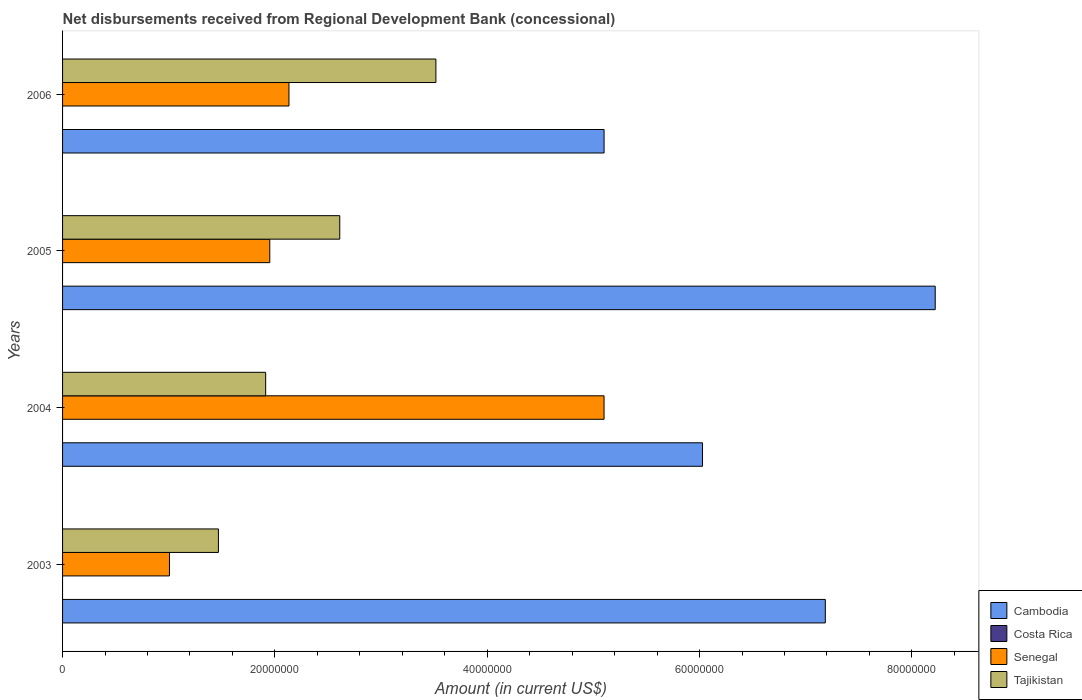How many groups of bars are there?
Your answer should be very brief. 4. Are the number of bars per tick equal to the number of legend labels?
Offer a terse response. No. How many bars are there on the 3rd tick from the bottom?
Your response must be concise. 3. What is the label of the 4th group of bars from the top?
Your response must be concise. 2003. In how many cases, is the number of bars for a given year not equal to the number of legend labels?
Give a very brief answer. 4. What is the amount of disbursements received from Regional Development Bank in Tajikistan in 2003?
Offer a terse response. 1.47e+07. Across all years, what is the maximum amount of disbursements received from Regional Development Bank in Cambodia?
Ensure brevity in your answer.  8.22e+07. Across all years, what is the minimum amount of disbursements received from Regional Development Bank in Cambodia?
Your response must be concise. 5.10e+07. What is the total amount of disbursements received from Regional Development Bank in Senegal in the graph?
Your answer should be compact. 1.02e+08. What is the difference between the amount of disbursements received from Regional Development Bank in Tajikistan in 2004 and that in 2005?
Make the answer very short. -6.98e+06. What is the difference between the amount of disbursements received from Regional Development Bank in Tajikistan in 2004 and the amount of disbursements received from Regional Development Bank in Senegal in 2003?
Your answer should be very brief. 9.06e+06. What is the average amount of disbursements received from Regional Development Bank in Cambodia per year?
Offer a terse response. 6.63e+07. In the year 2006, what is the difference between the amount of disbursements received from Regional Development Bank in Senegal and amount of disbursements received from Regional Development Bank in Cambodia?
Offer a terse response. -2.97e+07. In how many years, is the amount of disbursements received from Regional Development Bank in Cambodia greater than 68000000 US$?
Make the answer very short. 2. What is the ratio of the amount of disbursements received from Regional Development Bank in Senegal in 2004 to that in 2006?
Your response must be concise. 2.39. Is the difference between the amount of disbursements received from Regional Development Bank in Senegal in 2004 and 2006 greater than the difference between the amount of disbursements received from Regional Development Bank in Cambodia in 2004 and 2006?
Offer a terse response. Yes. What is the difference between the highest and the second highest amount of disbursements received from Regional Development Bank in Cambodia?
Your response must be concise. 1.04e+07. What is the difference between the highest and the lowest amount of disbursements received from Regional Development Bank in Senegal?
Provide a short and direct response. 4.09e+07. How many years are there in the graph?
Offer a terse response. 4. Are the values on the major ticks of X-axis written in scientific E-notation?
Offer a terse response. No. Does the graph contain any zero values?
Ensure brevity in your answer.  Yes. Where does the legend appear in the graph?
Offer a terse response. Bottom right. How are the legend labels stacked?
Keep it short and to the point. Vertical. What is the title of the graph?
Your answer should be compact. Net disbursements received from Regional Development Bank (concessional). What is the Amount (in current US$) of Cambodia in 2003?
Your response must be concise. 7.18e+07. What is the Amount (in current US$) of Costa Rica in 2003?
Give a very brief answer. 0. What is the Amount (in current US$) of Senegal in 2003?
Give a very brief answer. 1.01e+07. What is the Amount (in current US$) in Tajikistan in 2003?
Offer a terse response. 1.47e+07. What is the Amount (in current US$) of Cambodia in 2004?
Offer a terse response. 6.03e+07. What is the Amount (in current US$) of Senegal in 2004?
Offer a terse response. 5.10e+07. What is the Amount (in current US$) in Tajikistan in 2004?
Your answer should be compact. 1.91e+07. What is the Amount (in current US$) in Cambodia in 2005?
Offer a terse response. 8.22e+07. What is the Amount (in current US$) in Costa Rica in 2005?
Keep it short and to the point. 0. What is the Amount (in current US$) of Senegal in 2005?
Your response must be concise. 1.95e+07. What is the Amount (in current US$) of Tajikistan in 2005?
Your response must be concise. 2.61e+07. What is the Amount (in current US$) in Cambodia in 2006?
Provide a succinct answer. 5.10e+07. What is the Amount (in current US$) of Costa Rica in 2006?
Make the answer very short. 0. What is the Amount (in current US$) in Senegal in 2006?
Your answer should be compact. 2.13e+07. What is the Amount (in current US$) of Tajikistan in 2006?
Provide a short and direct response. 3.52e+07. Across all years, what is the maximum Amount (in current US$) in Cambodia?
Give a very brief answer. 8.22e+07. Across all years, what is the maximum Amount (in current US$) of Senegal?
Provide a succinct answer. 5.10e+07. Across all years, what is the maximum Amount (in current US$) of Tajikistan?
Your answer should be very brief. 3.52e+07. Across all years, what is the minimum Amount (in current US$) of Cambodia?
Provide a succinct answer. 5.10e+07. Across all years, what is the minimum Amount (in current US$) of Senegal?
Ensure brevity in your answer.  1.01e+07. Across all years, what is the minimum Amount (in current US$) of Tajikistan?
Keep it short and to the point. 1.47e+07. What is the total Amount (in current US$) of Cambodia in the graph?
Your answer should be compact. 2.65e+08. What is the total Amount (in current US$) of Senegal in the graph?
Your answer should be very brief. 1.02e+08. What is the total Amount (in current US$) of Tajikistan in the graph?
Your response must be concise. 9.51e+07. What is the difference between the Amount (in current US$) of Cambodia in 2003 and that in 2004?
Keep it short and to the point. 1.16e+07. What is the difference between the Amount (in current US$) in Senegal in 2003 and that in 2004?
Make the answer very short. -4.09e+07. What is the difference between the Amount (in current US$) of Tajikistan in 2003 and that in 2004?
Keep it short and to the point. -4.45e+06. What is the difference between the Amount (in current US$) of Cambodia in 2003 and that in 2005?
Keep it short and to the point. -1.04e+07. What is the difference between the Amount (in current US$) of Senegal in 2003 and that in 2005?
Give a very brief answer. -9.45e+06. What is the difference between the Amount (in current US$) in Tajikistan in 2003 and that in 2005?
Your answer should be very brief. -1.14e+07. What is the difference between the Amount (in current US$) in Cambodia in 2003 and that in 2006?
Keep it short and to the point. 2.08e+07. What is the difference between the Amount (in current US$) in Senegal in 2003 and that in 2006?
Your answer should be very brief. -1.13e+07. What is the difference between the Amount (in current US$) in Tajikistan in 2003 and that in 2006?
Give a very brief answer. -2.05e+07. What is the difference between the Amount (in current US$) of Cambodia in 2004 and that in 2005?
Ensure brevity in your answer.  -2.19e+07. What is the difference between the Amount (in current US$) in Senegal in 2004 and that in 2005?
Keep it short and to the point. 3.15e+07. What is the difference between the Amount (in current US$) of Tajikistan in 2004 and that in 2005?
Provide a short and direct response. -6.98e+06. What is the difference between the Amount (in current US$) of Cambodia in 2004 and that in 2006?
Ensure brevity in your answer.  9.27e+06. What is the difference between the Amount (in current US$) in Senegal in 2004 and that in 2006?
Offer a terse response. 2.97e+07. What is the difference between the Amount (in current US$) of Tajikistan in 2004 and that in 2006?
Ensure brevity in your answer.  -1.60e+07. What is the difference between the Amount (in current US$) in Cambodia in 2005 and that in 2006?
Offer a very short reply. 3.12e+07. What is the difference between the Amount (in current US$) of Senegal in 2005 and that in 2006?
Offer a very short reply. -1.80e+06. What is the difference between the Amount (in current US$) of Tajikistan in 2005 and that in 2006?
Provide a succinct answer. -9.06e+06. What is the difference between the Amount (in current US$) in Cambodia in 2003 and the Amount (in current US$) in Senegal in 2004?
Ensure brevity in your answer.  2.08e+07. What is the difference between the Amount (in current US$) in Cambodia in 2003 and the Amount (in current US$) in Tajikistan in 2004?
Make the answer very short. 5.27e+07. What is the difference between the Amount (in current US$) in Senegal in 2003 and the Amount (in current US$) in Tajikistan in 2004?
Offer a very short reply. -9.06e+06. What is the difference between the Amount (in current US$) of Cambodia in 2003 and the Amount (in current US$) of Senegal in 2005?
Offer a very short reply. 5.23e+07. What is the difference between the Amount (in current US$) in Cambodia in 2003 and the Amount (in current US$) in Tajikistan in 2005?
Offer a terse response. 4.57e+07. What is the difference between the Amount (in current US$) in Senegal in 2003 and the Amount (in current US$) in Tajikistan in 2005?
Offer a terse response. -1.60e+07. What is the difference between the Amount (in current US$) in Cambodia in 2003 and the Amount (in current US$) in Senegal in 2006?
Your answer should be very brief. 5.05e+07. What is the difference between the Amount (in current US$) in Cambodia in 2003 and the Amount (in current US$) in Tajikistan in 2006?
Keep it short and to the point. 3.67e+07. What is the difference between the Amount (in current US$) of Senegal in 2003 and the Amount (in current US$) of Tajikistan in 2006?
Offer a very short reply. -2.51e+07. What is the difference between the Amount (in current US$) in Cambodia in 2004 and the Amount (in current US$) in Senegal in 2005?
Make the answer very short. 4.08e+07. What is the difference between the Amount (in current US$) in Cambodia in 2004 and the Amount (in current US$) in Tajikistan in 2005?
Your answer should be very brief. 3.42e+07. What is the difference between the Amount (in current US$) in Senegal in 2004 and the Amount (in current US$) in Tajikistan in 2005?
Ensure brevity in your answer.  2.49e+07. What is the difference between the Amount (in current US$) of Cambodia in 2004 and the Amount (in current US$) of Senegal in 2006?
Ensure brevity in your answer.  3.90e+07. What is the difference between the Amount (in current US$) in Cambodia in 2004 and the Amount (in current US$) in Tajikistan in 2006?
Provide a succinct answer. 2.51e+07. What is the difference between the Amount (in current US$) in Senegal in 2004 and the Amount (in current US$) in Tajikistan in 2006?
Ensure brevity in your answer.  1.58e+07. What is the difference between the Amount (in current US$) in Cambodia in 2005 and the Amount (in current US$) in Senegal in 2006?
Offer a very short reply. 6.09e+07. What is the difference between the Amount (in current US$) of Cambodia in 2005 and the Amount (in current US$) of Tajikistan in 2006?
Your response must be concise. 4.70e+07. What is the difference between the Amount (in current US$) of Senegal in 2005 and the Amount (in current US$) of Tajikistan in 2006?
Provide a short and direct response. -1.56e+07. What is the average Amount (in current US$) in Cambodia per year?
Offer a very short reply. 6.63e+07. What is the average Amount (in current US$) of Costa Rica per year?
Offer a very short reply. 0. What is the average Amount (in current US$) of Senegal per year?
Provide a short and direct response. 2.55e+07. What is the average Amount (in current US$) of Tajikistan per year?
Ensure brevity in your answer.  2.38e+07. In the year 2003, what is the difference between the Amount (in current US$) in Cambodia and Amount (in current US$) in Senegal?
Ensure brevity in your answer.  6.18e+07. In the year 2003, what is the difference between the Amount (in current US$) in Cambodia and Amount (in current US$) in Tajikistan?
Make the answer very short. 5.72e+07. In the year 2003, what is the difference between the Amount (in current US$) of Senegal and Amount (in current US$) of Tajikistan?
Give a very brief answer. -4.61e+06. In the year 2004, what is the difference between the Amount (in current US$) of Cambodia and Amount (in current US$) of Senegal?
Offer a very short reply. 9.27e+06. In the year 2004, what is the difference between the Amount (in current US$) of Cambodia and Amount (in current US$) of Tajikistan?
Ensure brevity in your answer.  4.11e+07. In the year 2004, what is the difference between the Amount (in current US$) of Senegal and Amount (in current US$) of Tajikistan?
Give a very brief answer. 3.19e+07. In the year 2005, what is the difference between the Amount (in current US$) in Cambodia and Amount (in current US$) in Senegal?
Provide a short and direct response. 6.27e+07. In the year 2005, what is the difference between the Amount (in current US$) in Cambodia and Amount (in current US$) in Tajikistan?
Give a very brief answer. 5.61e+07. In the year 2005, what is the difference between the Amount (in current US$) in Senegal and Amount (in current US$) in Tajikistan?
Provide a short and direct response. -6.59e+06. In the year 2006, what is the difference between the Amount (in current US$) of Cambodia and Amount (in current US$) of Senegal?
Offer a terse response. 2.97e+07. In the year 2006, what is the difference between the Amount (in current US$) of Cambodia and Amount (in current US$) of Tajikistan?
Your response must be concise. 1.58e+07. In the year 2006, what is the difference between the Amount (in current US$) in Senegal and Amount (in current US$) in Tajikistan?
Make the answer very short. -1.38e+07. What is the ratio of the Amount (in current US$) in Cambodia in 2003 to that in 2004?
Provide a succinct answer. 1.19. What is the ratio of the Amount (in current US$) in Senegal in 2003 to that in 2004?
Ensure brevity in your answer.  0.2. What is the ratio of the Amount (in current US$) of Tajikistan in 2003 to that in 2004?
Keep it short and to the point. 0.77. What is the ratio of the Amount (in current US$) in Cambodia in 2003 to that in 2005?
Your answer should be very brief. 0.87. What is the ratio of the Amount (in current US$) in Senegal in 2003 to that in 2005?
Give a very brief answer. 0.52. What is the ratio of the Amount (in current US$) of Tajikistan in 2003 to that in 2005?
Your response must be concise. 0.56. What is the ratio of the Amount (in current US$) in Cambodia in 2003 to that in 2006?
Your answer should be compact. 1.41. What is the ratio of the Amount (in current US$) of Senegal in 2003 to that in 2006?
Offer a terse response. 0.47. What is the ratio of the Amount (in current US$) in Tajikistan in 2003 to that in 2006?
Your answer should be compact. 0.42. What is the ratio of the Amount (in current US$) in Cambodia in 2004 to that in 2005?
Give a very brief answer. 0.73. What is the ratio of the Amount (in current US$) of Senegal in 2004 to that in 2005?
Make the answer very short. 2.61. What is the ratio of the Amount (in current US$) in Tajikistan in 2004 to that in 2005?
Make the answer very short. 0.73. What is the ratio of the Amount (in current US$) of Cambodia in 2004 to that in 2006?
Your answer should be compact. 1.18. What is the ratio of the Amount (in current US$) in Senegal in 2004 to that in 2006?
Offer a terse response. 2.39. What is the ratio of the Amount (in current US$) of Tajikistan in 2004 to that in 2006?
Give a very brief answer. 0.54. What is the ratio of the Amount (in current US$) in Cambodia in 2005 to that in 2006?
Give a very brief answer. 1.61. What is the ratio of the Amount (in current US$) in Senegal in 2005 to that in 2006?
Give a very brief answer. 0.92. What is the ratio of the Amount (in current US$) in Tajikistan in 2005 to that in 2006?
Your answer should be very brief. 0.74. What is the difference between the highest and the second highest Amount (in current US$) of Cambodia?
Provide a succinct answer. 1.04e+07. What is the difference between the highest and the second highest Amount (in current US$) in Senegal?
Offer a very short reply. 2.97e+07. What is the difference between the highest and the second highest Amount (in current US$) of Tajikistan?
Make the answer very short. 9.06e+06. What is the difference between the highest and the lowest Amount (in current US$) of Cambodia?
Give a very brief answer. 3.12e+07. What is the difference between the highest and the lowest Amount (in current US$) in Senegal?
Offer a very short reply. 4.09e+07. What is the difference between the highest and the lowest Amount (in current US$) in Tajikistan?
Provide a short and direct response. 2.05e+07. 